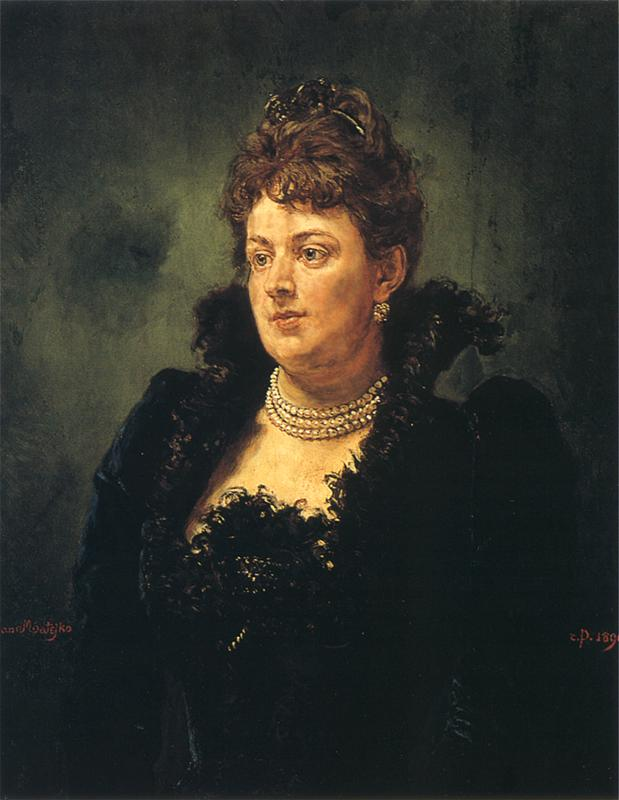Can you tell me more about the background and technique used in this painting? Certainly! The background of the painting is composed of a rich blend of dark tones such as green, black, and brown. This choice of palette serves to emphasize the figure's presence and provide a strong contrast to her lighter skin and the dark elegance of her attire. The technique used here appears to be influenced by the impressionist style, which is characterized by loose brush strokes and an emphasis on capturing the interplay of light and shadow rather than fine details. This method allows the viewer to focus more on the overall atmosphere and emotional tone of the portrait. The use of light and shadow subtly directs the viewer's attention to the woman's face and her expressive gaze, making her the undeniable focal point of the artwork. What emotions do you think the artist is trying to convey through this portrait? The artist seems to be conveying a complex mix of emotions through this portrait. The woman's gaze, directed beyond the frame, suggests a sense of introspection or contemplation. Her expression is soft yet serious, possibly indicating feelings of nostalgia or melancholy. The elegant attire and refined accessories add an air of dignity and grace, suggesting that she carries herself with a quiet strength. The dark, muted background contrasts with the light on her face, further emphasizing the introspective mood of the piece. Overall, the portrait evokes a sense of mystery and depth, inviting viewers to ponder the inner thoughts and emotions of the subject. 